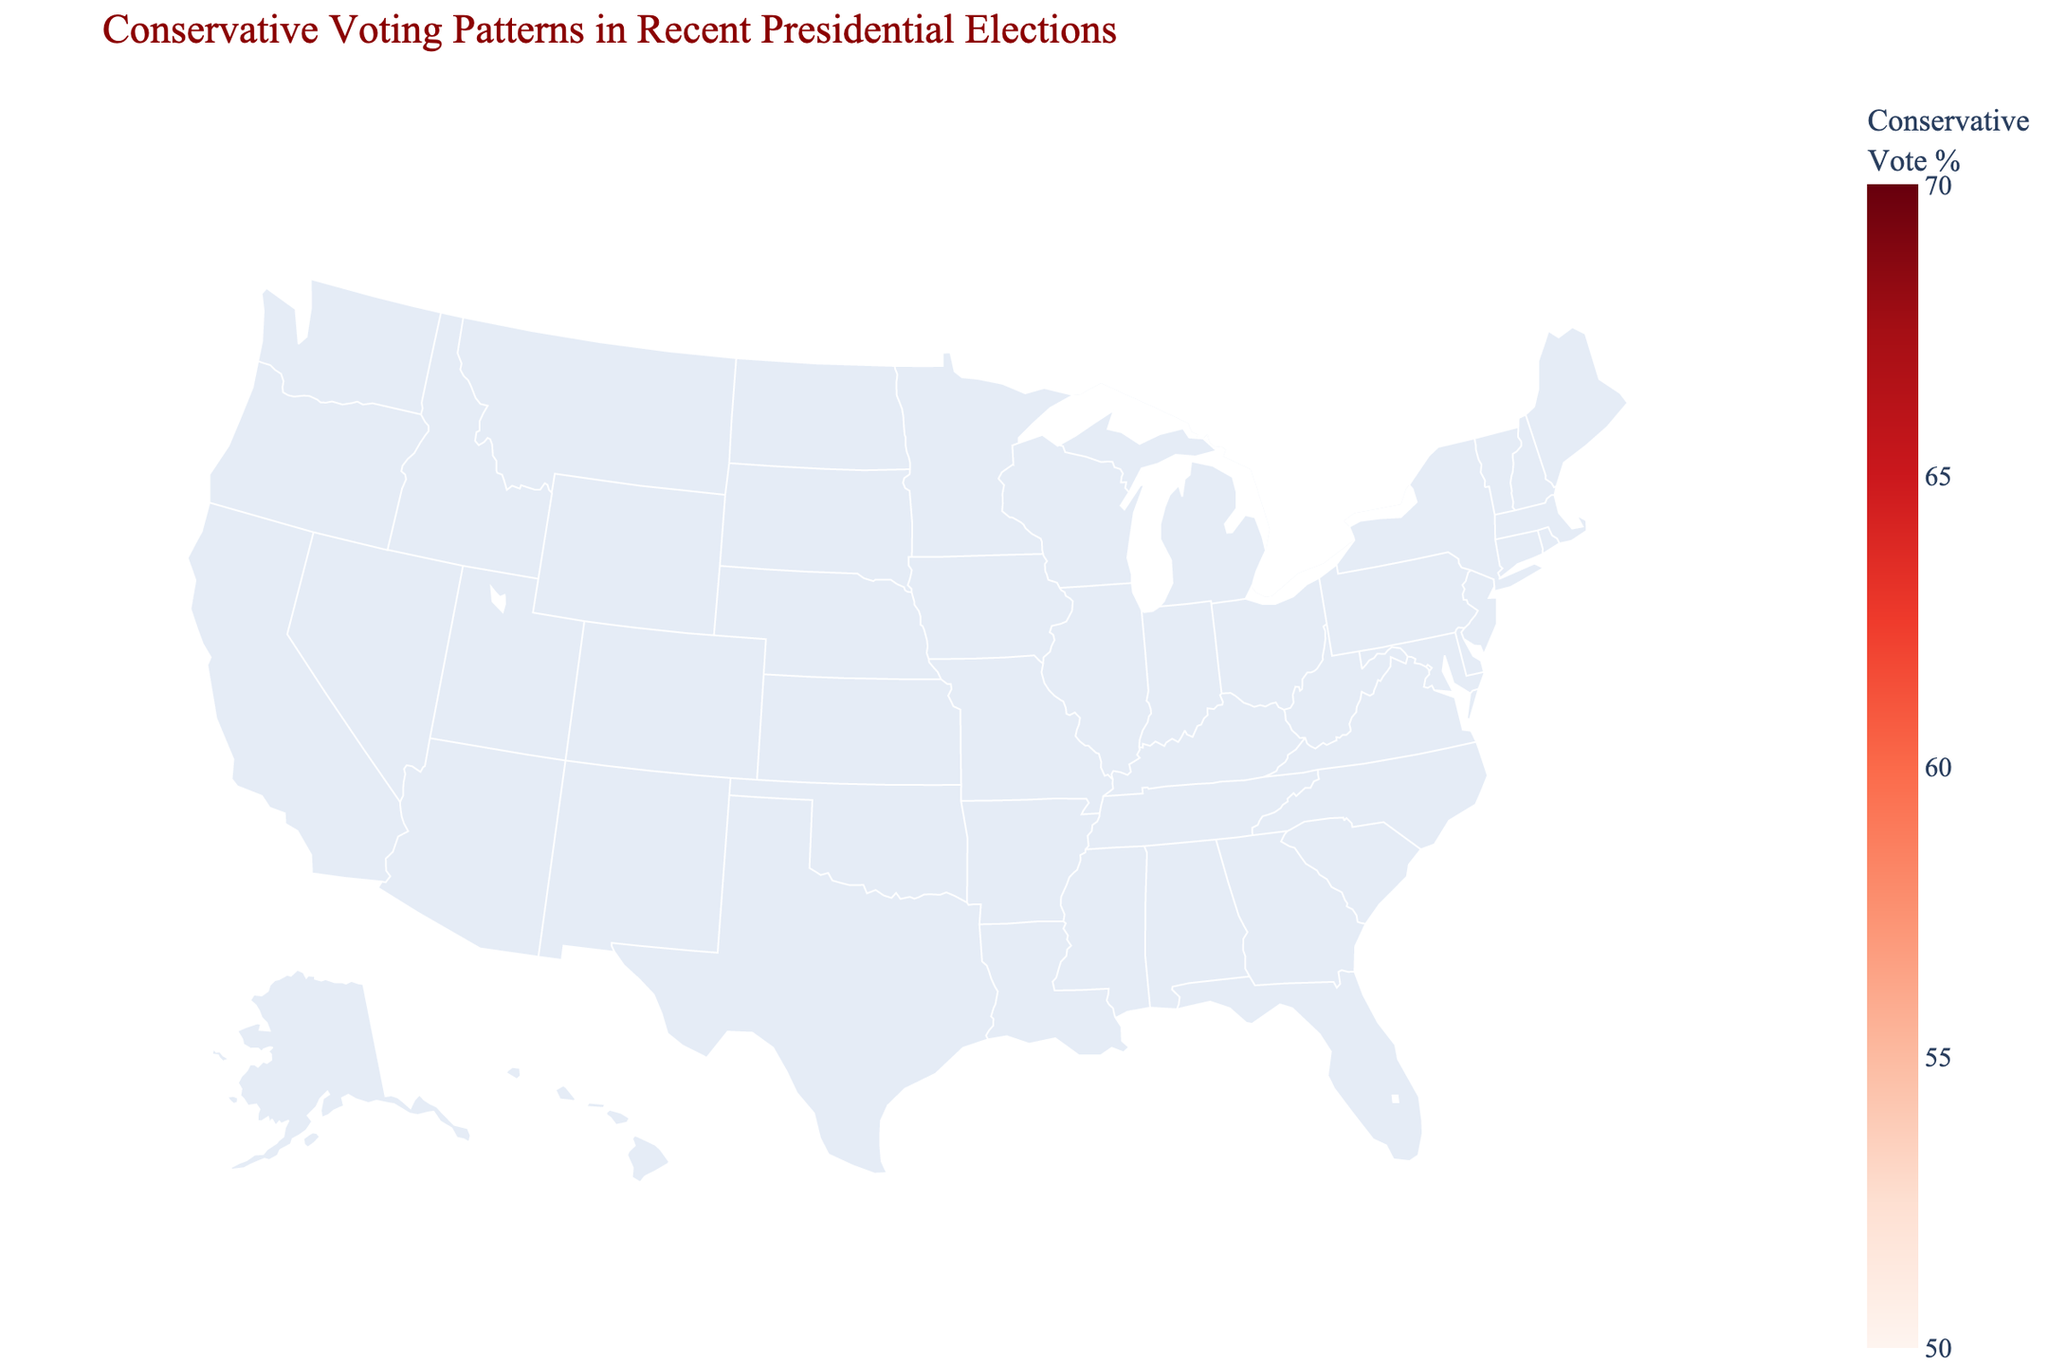What is the title of the figure? The title is displayed at the top of the figure and reads "Conservative Voting Patterns in Recent Presidential Elections."
Answer: Conservative Voting Patterns in Recent Presidential Elections Which state has the highest conservative vote percentage? By looking at the annotations on the figure, Wyoming has the highest conservative vote percentage shown as 69.9%.
Answer: Wyoming How many Southern states are represented in the plot? By counting the states labeled with 'South' in the data table, there are 10 Southern states: Alabama, Mississippi, Tennessee, Arkansas, Louisiana, Kentucky, West Virginia, South Carolina, Texas, and Missouri.
Answer: 10 What is the average conservative vote percentage for the Midwest region? The Midwest states in the data are North Dakota (65.1), South Dakota (61.8), Nebraska (58.7), Kansas (56.2), and Missouri (56.8). The average is calculated as (65.1 + 61.8 + 58.7 + 56.2 + 56.8) / 5 = 59.72%.
Answer: 59.72% Which region has the least number of states represented in the plot? By counting the number of states in each region in the data table: South (10), West (5), Midwest (5). The Central region is represented by only one state - Oklahoma.
Answer: Central Compare the conservative vote percentages of Texas and Alaska. Which state has a higher value? From the figure, Texas has a conservative vote percentage of 52.1% and Alaska has 52.8%. Therefore, Alaska has a higher value.
Answer: Alaska What is the range of conservative vote percentages shown in the plot? The lowest percentage shown is Texas with 52.1% and the highest percentage is Wyoming with 69.9%. The range would be 69.9% - 52.1% = 17.8%.
Answer: 17.8% Which Western state has the lowest conservative vote percentage? By looking at the Western region states in the data, Alaska has the lowest conservative vote percentage at 52.8%.
Answer: Alaska How does the conservative vote percentage in Oklahoma compare to that in Utah? Oklahoma has a conservative vote percentage of 65.4%, while Utah has 58.1%, making Oklahoma higher by 7.3%.
Answer: Oklahoma 